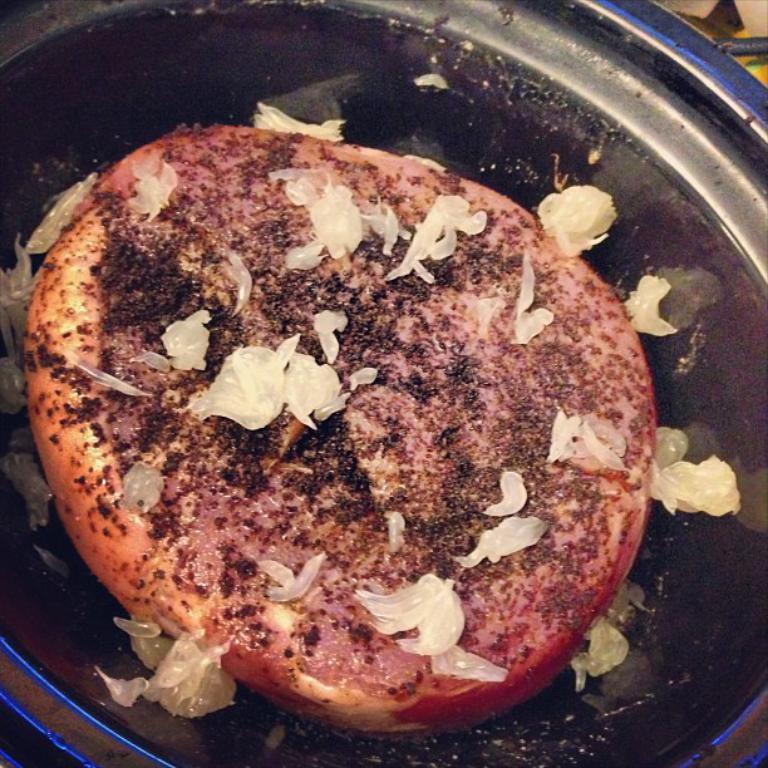In one or two sentences, can you explain what this image depicts? Here we can see a food item in a bowl and on the right at the top corner the image is not clear to describe. 